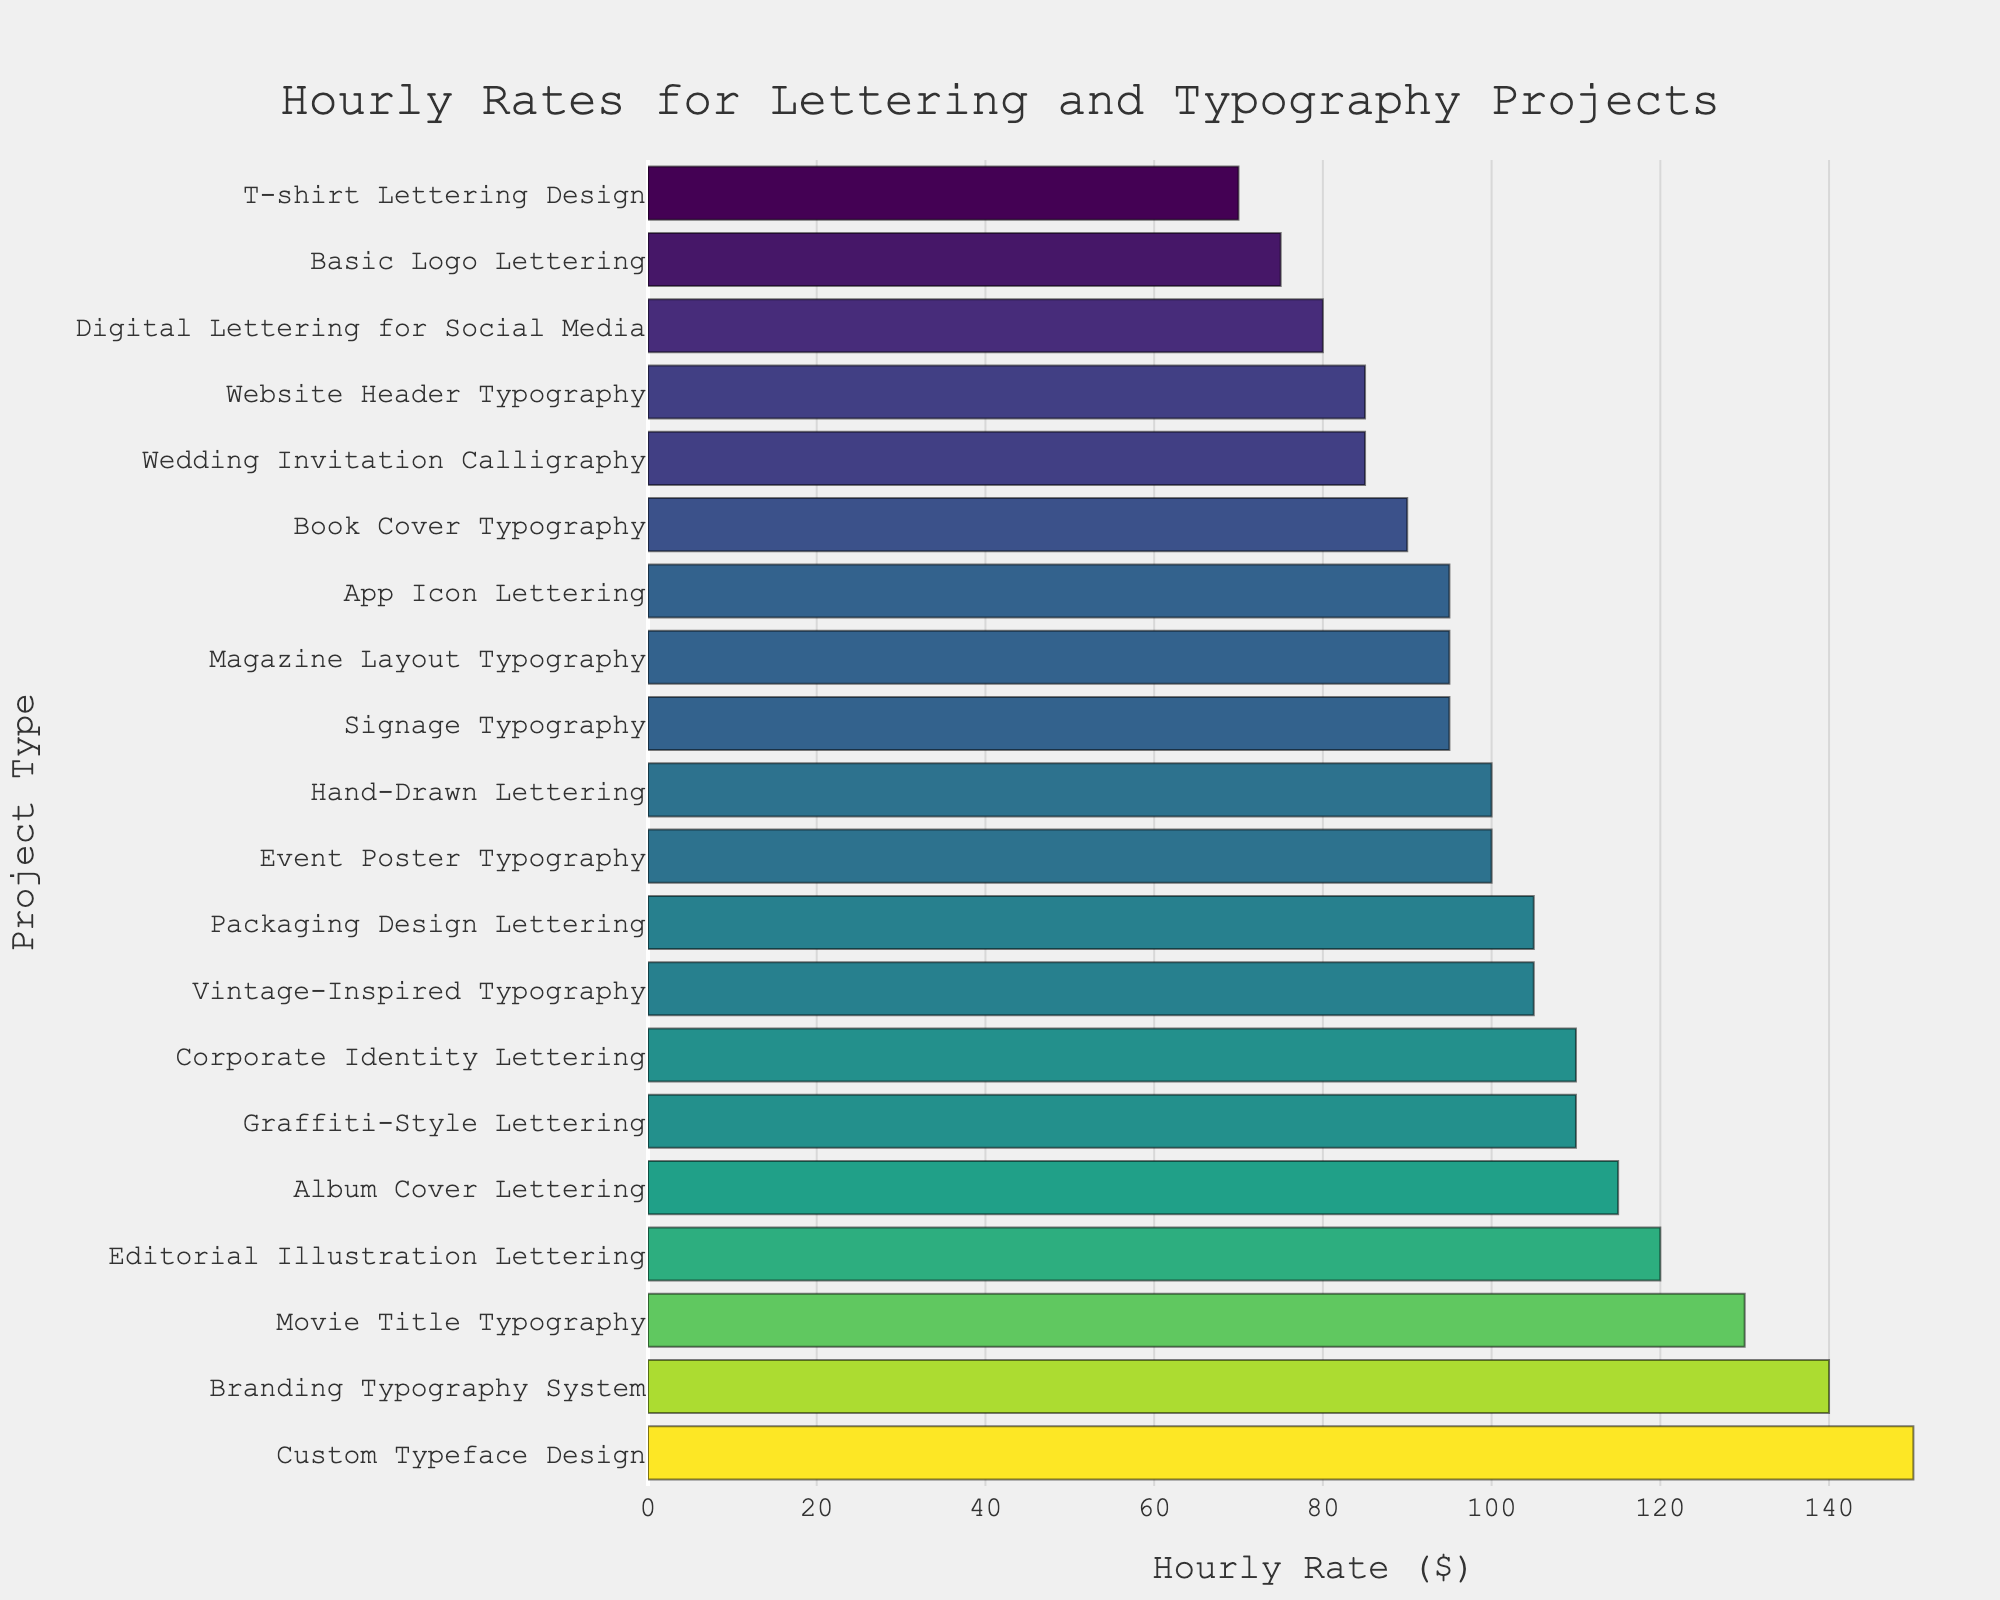Which project type has the highest hourly rate? To determine the project type with the highest hourly rate, we look for the bar that extends farthest to the right. This is the highest value in the horizontal bar chart.
Answer: Custom Typeface Design What is the difference in hourly rates between Book Cover Typography and Wedding Invitation Calligraphy? Locate the bars for Book Cover Typography ($90) and Wedding Invitation Calligraphy ($85). Subtract the lower rate from the higher rate: $90 - $85.
Answer: $5 Which project type has a higher hourly rate: Album Cover Lettering or Digital Lettering for Social Media? Compare the lengths of the bars representing Album Cover Lettering ($115) and Digital Lettering for Social Media ($80). The bar for Album Cover Lettering is longer.
Answer: Album Cover Lettering What is the average hourly rate of Corporate Identity Lettering, Packaging Design Lettering, and Event Poster Typography? Add the rates of Corporate Identity Lettering ($110), Packaging Design Lettering ($105), and Event Poster Typography ($100), then divide by 3: ($110 + $105 + $100) / 3.
Answer: $105 Which two project types have the closest hourly rates and what are those rates? Examine the bars to identify which two are closest in length. Notice that Magazine Layout Typography and Signage Typography both have hourly rates of $95.
Answer: Magazine Layout Typography and Signage Typography; $95 How many project types have an hourly rate of $100 or more? Count the bars that reach or exceed the $100 mark. They are Custom Typeface Design, Editorial Illustration Lettering, Movie Title Typography, Album Cover Lettering, Branding Typography System, and Corporate Identity Lettering.
Answer: 6 What is the median hourly rate of all the project types? First, order all rates from lowest to highest. The 10th and 11th rates, as it's an even number of items, are both $95 and $100 respectively. So, the median is (95 + 100) / 2.
Answer: $97.5 Which project type has the second lowest hourly rate? Locate the second shortest bar, which is T-shirt Lettering Design ($70). The Basic Logo Lettering ($75) is next.
Answer: Basic Logo Lettering 